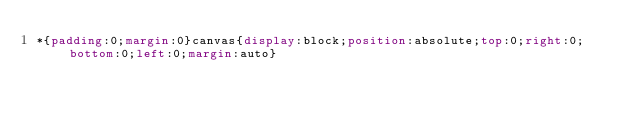Convert code to text. <code><loc_0><loc_0><loc_500><loc_500><_CSS_>*{padding:0;margin:0}canvas{display:block;position:absolute;top:0;right:0;bottom:0;left:0;margin:auto}</code> 